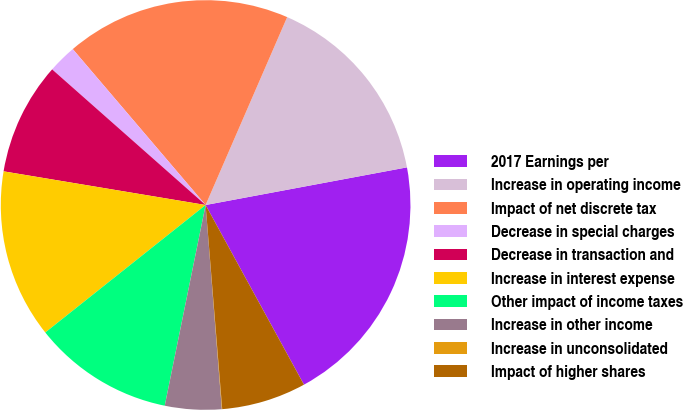Convert chart to OTSL. <chart><loc_0><loc_0><loc_500><loc_500><pie_chart><fcel>2017 Earnings per<fcel>Increase in operating income<fcel>Impact of net discrete tax<fcel>Decrease in special charges<fcel>Decrease in transaction and<fcel>Increase in interest expense<fcel>Other impact of income taxes<fcel>Increase in other income<fcel>Increase in unconsolidated<fcel>Impact of higher shares<nl><fcel>19.97%<fcel>15.54%<fcel>17.75%<fcel>2.25%<fcel>8.89%<fcel>13.32%<fcel>11.11%<fcel>4.46%<fcel>0.03%<fcel>6.68%<nl></chart> 